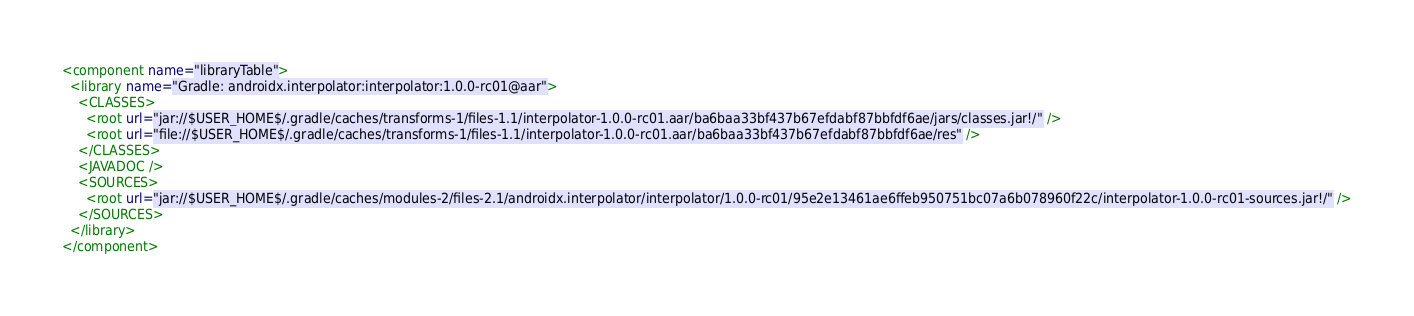<code> <loc_0><loc_0><loc_500><loc_500><_XML_><component name="libraryTable">
  <library name="Gradle: androidx.interpolator:interpolator:1.0.0-rc01@aar">
    <CLASSES>
      <root url="jar://$USER_HOME$/.gradle/caches/transforms-1/files-1.1/interpolator-1.0.0-rc01.aar/ba6baa33bf437b67efdabf87bbfdf6ae/jars/classes.jar!/" />
      <root url="file://$USER_HOME$/.gradle/caches/transforms-1/files-1.1/interpolator-1.0.0-rc01.aar/ba6baa33bf437b67efdabf87bbfdf6ae/res" />
    </CLASSES>
    <JAVADOC />
    <SOURCES>
      <root url="jar://$USER_HOME$/.gradle/caches/modules-2/files-2.1/androidx.interpolator/interpolator/1.0.0-rc01/95e2e13461ae6ffeb950751bc07a6b078960f22c/interpolator-1.0.0-rc01-sources.jar!/" />
    </SOURCES>
  </library>
</component></code> 